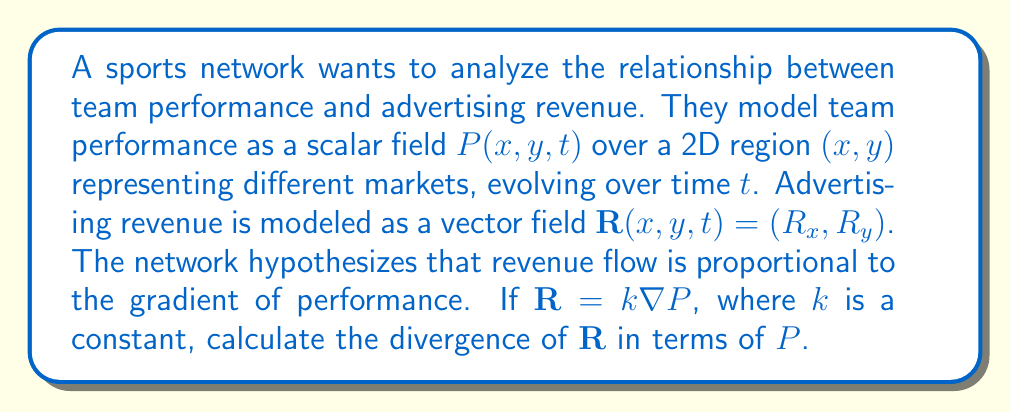What is the answer to this math problem? 1) We start with the given relationship: $\mathbf{R} = k\nabla P$

2) The gradient of P in 2D is:
   $$\nabla P = \left(\frac{\partial P}{\partial x}, \frac{\partial P}{\partial y}\right)$$

3) Therefore, we can express R as:
   $$\mathbf{R} = k\left(\frac{\partial P}{\partial x}, \frac{\partial P}{\partial y}\right)$$

4) The divergence of a 2D vector field $\mathbf{F} = (F_x, F_y)$ is given by:
   $$\nabla \cdot \mathbf{F} = \frac{\partial F_x}{\partial x} + \frac{\partial F_y}{\partial y}$$

5) In our case, $R_x = k\frac{\partial P}{\partial x}$ and $R_y = k\frac{\partial P}{\partial y}$

6) Applying the divergence formula:
   $$\nabla \cdot \mathbf{R} = \frac{\partial}{\partial x}\left(k\frac{\partial P}{\partial x}\right) + \frac{\partial}{\partial y}\left(k\frac{\partial P}{\partial y}\right)$$

7) Since k is constant, we can factor it out:
   $$\nabla \cdot \mathbf{R} = k\left(\frac{\partial^2 P}{\partial x^2} + \frac{\partial^2 P}{\partial y^2}\right)$$

8) The expression in parentheses is the Laplacian of P in 2D, denoted as $\nabla^2 P$

Therefore, the final result is:
$$\nabla \cdot \mathbf{R} = k\nabla^2 P$$
Answer: $k\nabla^2 P$ 